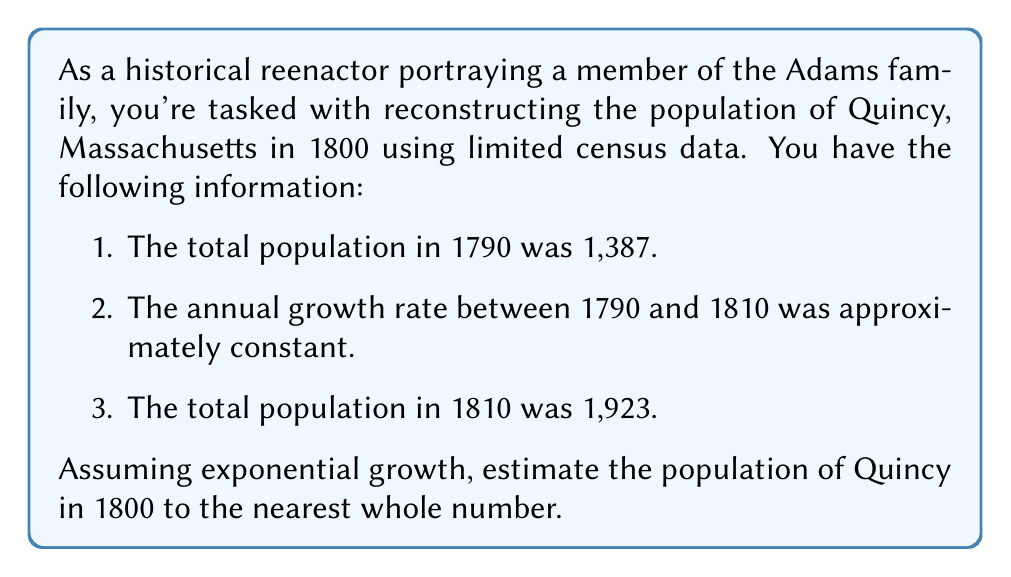Teach me how to tackle this problem. To solve this inverse problem, we'll use the exponential growth model and the given data to reconstruct the population in 1800. Let's approach this step-by-step:

1. Let $P(t)$ be the population at time $t$, where $t$ is the number of years since 1790.
2. The exponential growth model is given by $P(t) = P_0 e^{rt}$, where $P_0$ is the initial population and $r$ is the growth rate.

3. We know:
   $P(0) = 1,387$ (population in 1790)
   $P(20) = 1,923$ (population in 1810)

4. Using these values in the exponential growth equation:
   $1,923 = 1,387 e^{20r}$

5. Solve for $r$:
   $\frac{1,923}{1,387} = e^{20r}$
   $\ln(\frac{1,923}{1,387}) = 20r$
   $r = \frac{\ln(\frac{1,923}{1,387})}{20} \approx 0.01627$

6. Now that we have $r$, we can find the population in 1800 (which is 10 years after 1790):
   $P(10) = 1,387 e^{10 * 0.01627}$

7. Calculate:
   $P(10) = 1,387 * e^{0.1627} \approx 1,632.48$

8. Rounding to the nearest whole number:
   $P(10) \approx 1,632$

Therefore, the estimated population of Quincy in 1800 is 1,632.
Answer: 1,632 